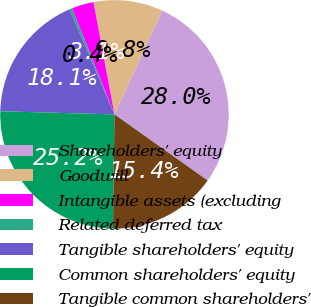<chart> <loc_0><loc_0><loc_500><loc_500><pie_chart><fcel>Shareholders' equity<fcel>Goodwill<fcel>Intangible assets (excluding<fcel>Related deferred tax<fcel>Tangible shareholders' equity<fcel>Common shareholders' equity<fcel>Tangible common shareholders'<nl><fcel>27.97%<fcel>9.8%<fcel>3.12%<fcel>0.38%<fcel>18.12%<fcel>25.23%<fcel>15.38%<nl></chart> 